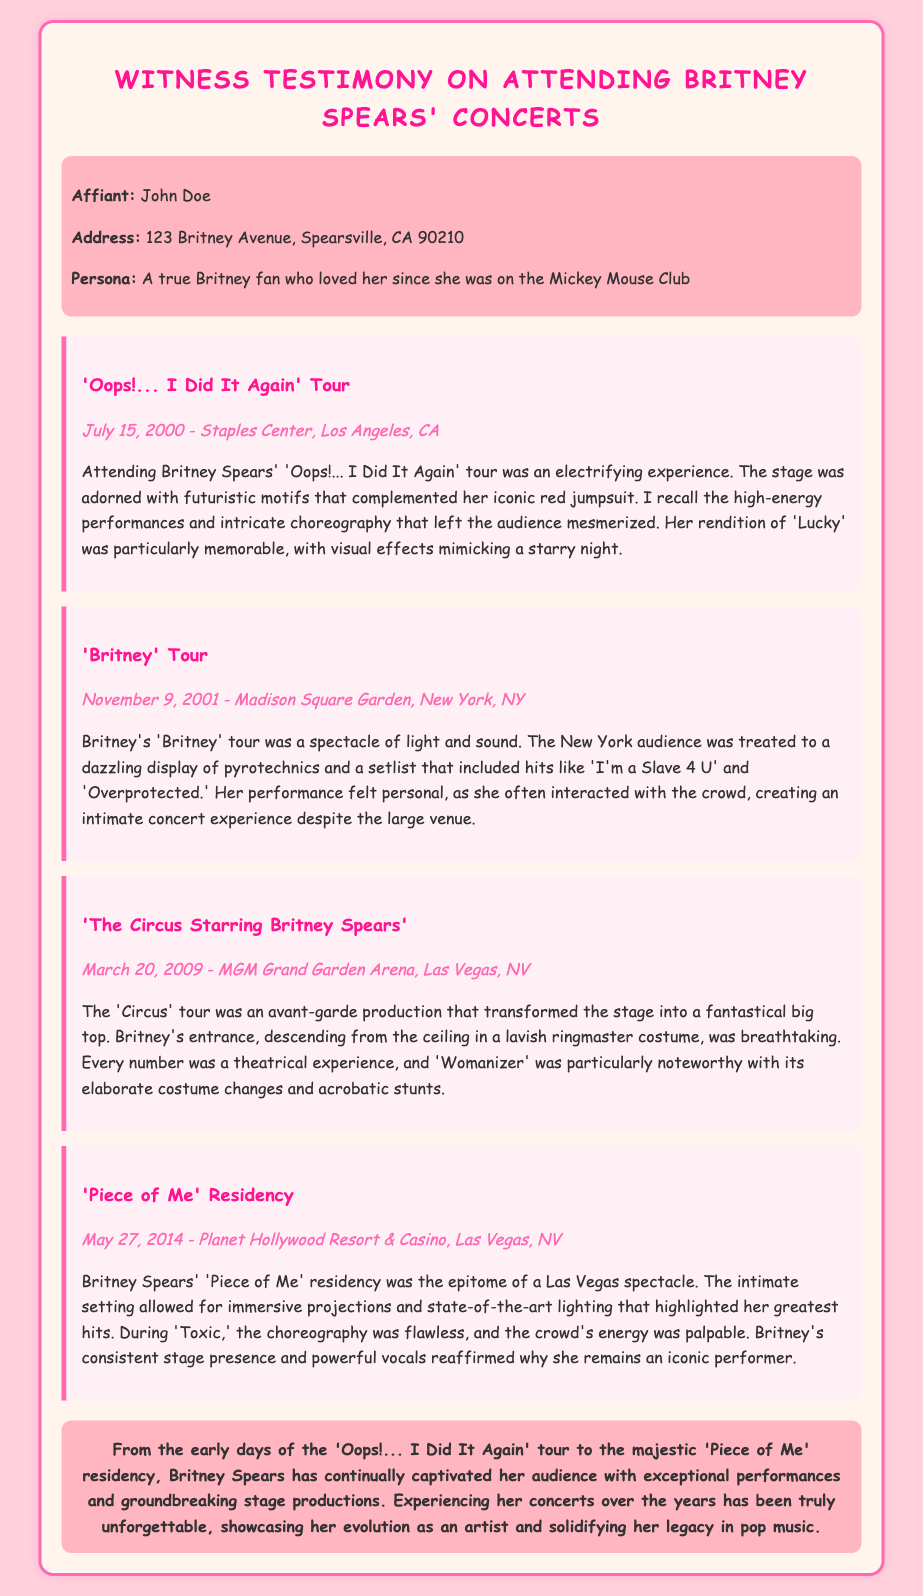what is the name of the first tour mentioned? The first tour mentioned is the 'Oops!... I Did It Again' tour.
Answer: 'Oops!... I Did It Again' tour what date did the 'Britney' tour take place? The 'Britney' tour took place on November 9, 2001.
Answer: November 9, 2001 which venue hosted the 'Piece of Me' residency? The 'Piece of Me' residency was hosted at Planet Hollywood Resort & Casino.
Answer: Planet Hollywood Resort & Casino what was a key feature of the 'Circus' tour? A key feature of the 'Circus' tour was Britney's entrance descending from the ceiling in a ringmaster costume.
Answer: Descending from the ceiling in a ringmaster costume how many concert experiences are detailed in the affidavit? The affidavit details four concert experiences.
Answer: Four what emotion did the witness feel during the concerts? The witness felt electrified during the concerts.
Answer: Electrified which song was performed during the 'Oops!... I Did It Again' tour that stood out? The song that stood out during the 'Oops!... I Did It Again' tour was 'Lucky.'
Answer: 'Lucky' what is the purpose of this affidavit? The purpose of the affidavit is to provide witness testimony about attending Britney Spears' concerts.
Answer: Witness testimony about attending concerts who is the affiant? The affiant is John Doe.
Answer: John Doe 